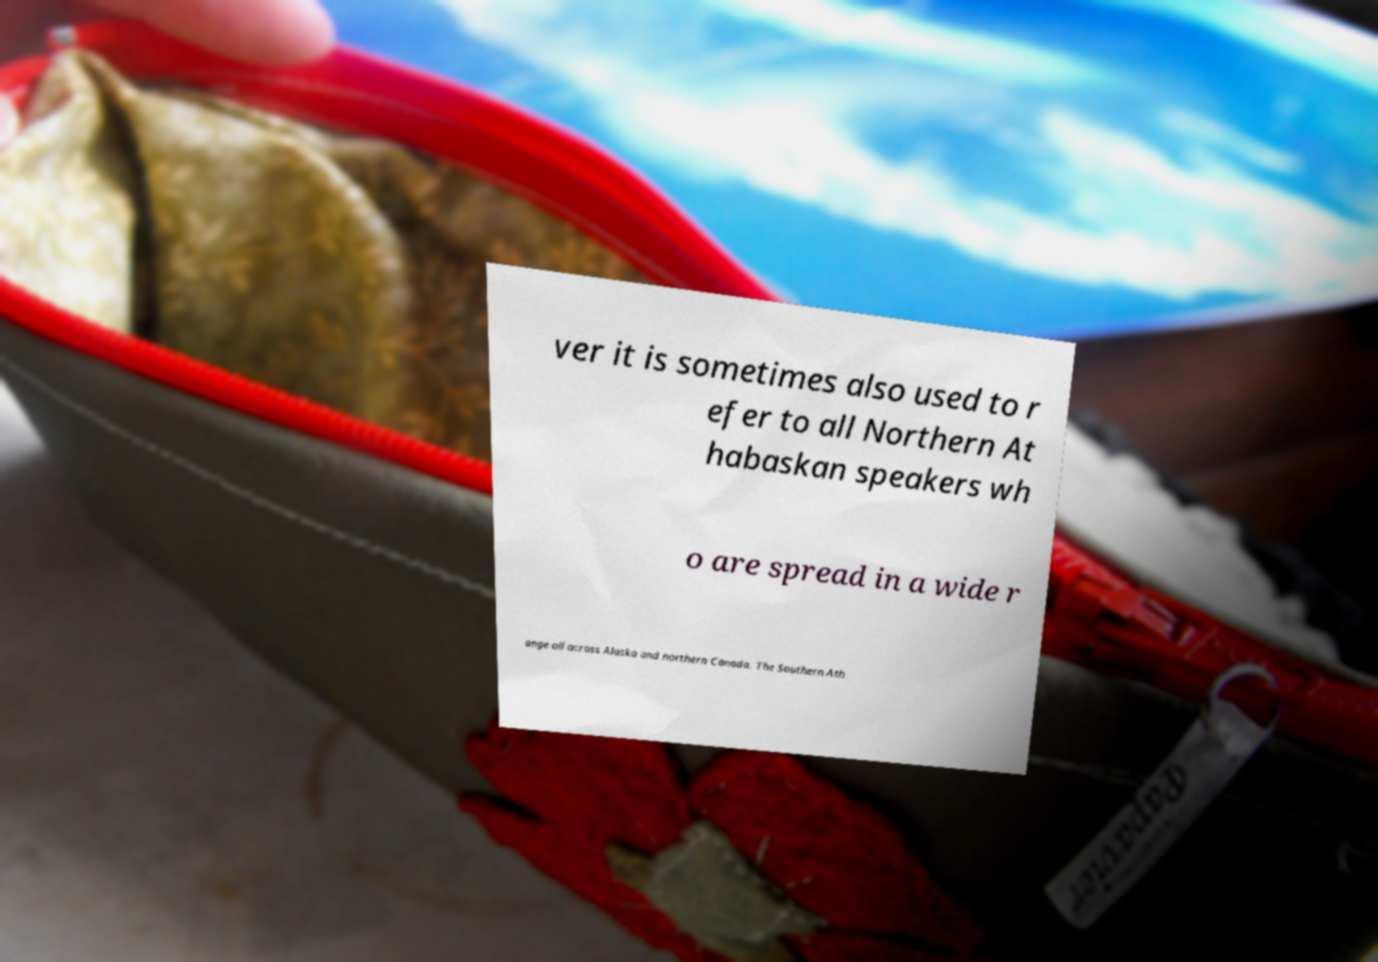Could you extract and type out the text from this image? ver it is sometimes also used to r efer to all Northern At habaskan speakers wh o are spread in a wide r ange all across Alaska and northern Canada. The Southern Ath 